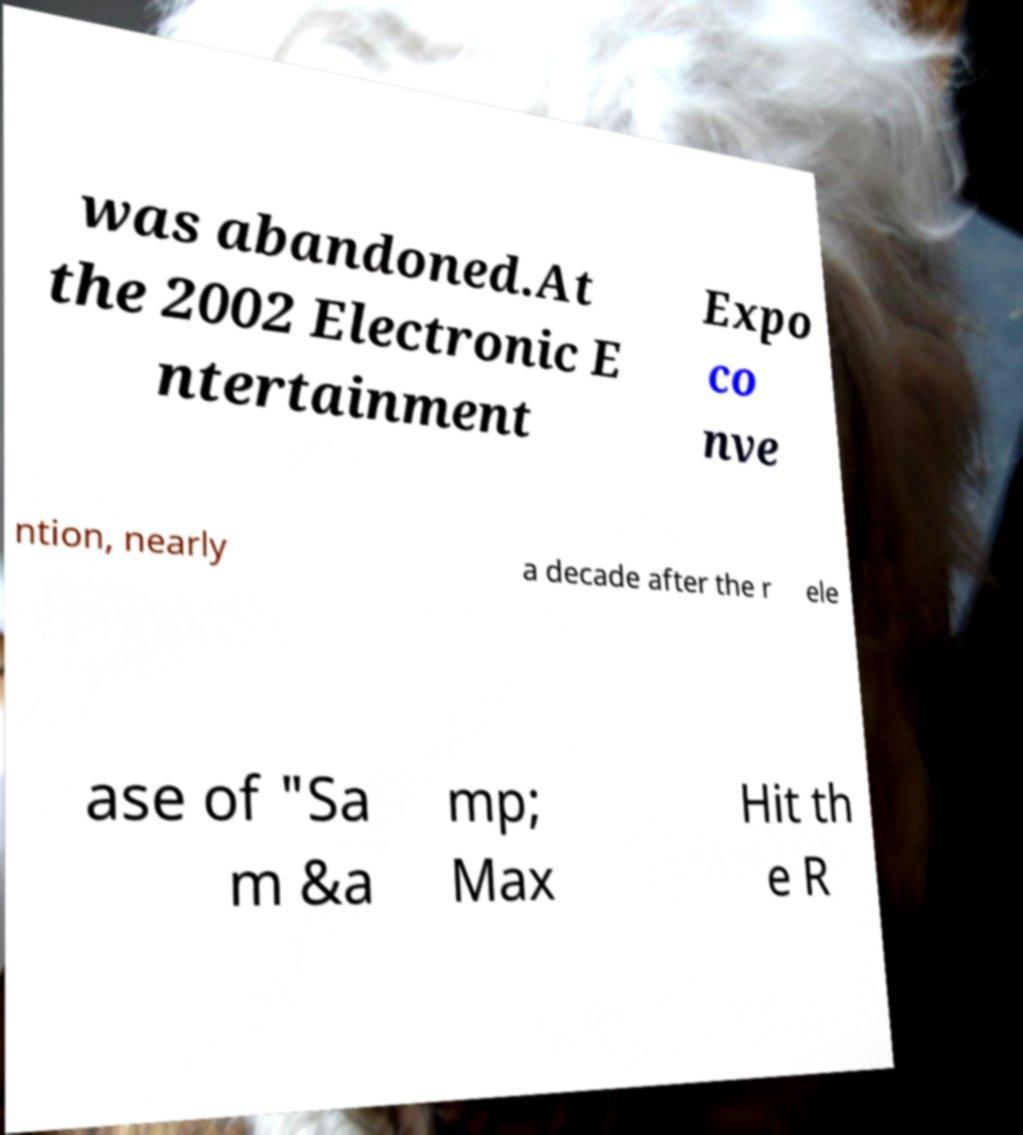Could you assist in decoding the text presented in this image and type it out clearly? was abandoned.At the 2002 Electronic E ntertainment Expo co nve ntion, nearly a decade after the r ele ase of "Sa m &a mp; Max Hit th e R 